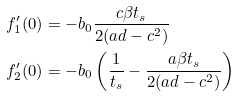<formula> <loc_0><loc_0><loc_500><loc_500>f _ { 1 } ^ { \prime } ( 0 ) & = - b _ { 0 } \frac { c \beta t _ { s } } { 2 ( a d - c ^ { 2 } ) } \\ f _ { 2 } ^ { \prime } ( 0 ) & = - b _ { 0 } \left ( \frac { 1 } { t _ { s } } - \frac { a \beta t _ { s } } { 2 ( a d - c ^ { 2 } ) } \right )</formula> 